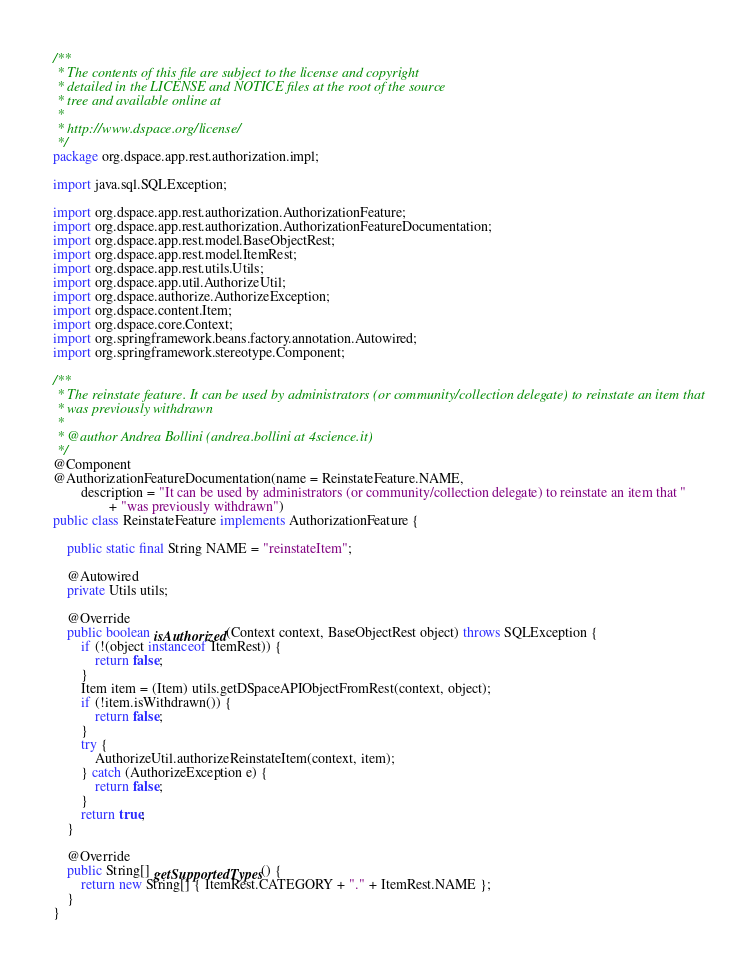Convert code to text. <code><loc_0><loc_0><loc_500><loc_500><_Java_>/**
 * The contents of this file are subject to the license and copyright
 * detailed in the LICENSE and NOTICE files at the root of the source
 * tree and available online at
 *
 * http://www.dspace.org/license/
 */
package org.dspace.app.rest.authorization.impl;

import java.sql.SQLException;

import org.dspace.app.rest.authorization.AuthorizationFeature;
import org.dspace.app.rest.authorization.AuthorizationFeatureDocumentation;
import org.dspace.app.rest.model.BaseObjectRest;
import org.dspace.app.rest.model.ItemRest;
import org.dspace.app.rest.utils.Utils;
import org.dspace.app.util.AuthorizeUtil;
import org.dspace.authorize.AuthorizeException;
import org.dspace.content.Item;
import org.dspace.core.Context;
import org.springframework.beans.factory.annotation.Autowired;
import org.springframework.stereotype.Component;

/**
 * The reinstate feature. It can be used by administrators (or community/collection delegate) to reinstate an item that
 * was previously withdrawn
 *
 * @author Andrea Bollini (andrea.bollini at 4science.it)
 */
@Component
@AuthorizationFeatureDocumentation(name = ReinstateFeature.NAME,
        description = "It can be used by administrators (or community/collection delegate) to reinstate an item that "
                + "was previously withdrawn")
public class ReinstateFeature implements AuthorizationFeature {

    public static final String NAME = "reinstateItem";

    @Autowired
    private Utils utils;

    @Override
    public boolean isAuthorized(Context context, BaseObjectRest object) throws SQLException {
        if (!(object instanceof ItemRest)) {
            return false;
        }
        Item item = (Item) utils.getDSpaceAPIObjectFromRest(context, object);
        if (!item.isWithdrawn()) {
            return false;
        }
        try {
            AuthorizeUtil.authorizeReinstateItem(context, item);
        } catch (AuthorizeException e) {
            return false;
        }
        return true;
    }

    @Override
    public String[] getSupportedTypes() {
        return new String[] { ItemRest.CATEGORY + "." + ItemRest.NAME };
    }
}</code> 